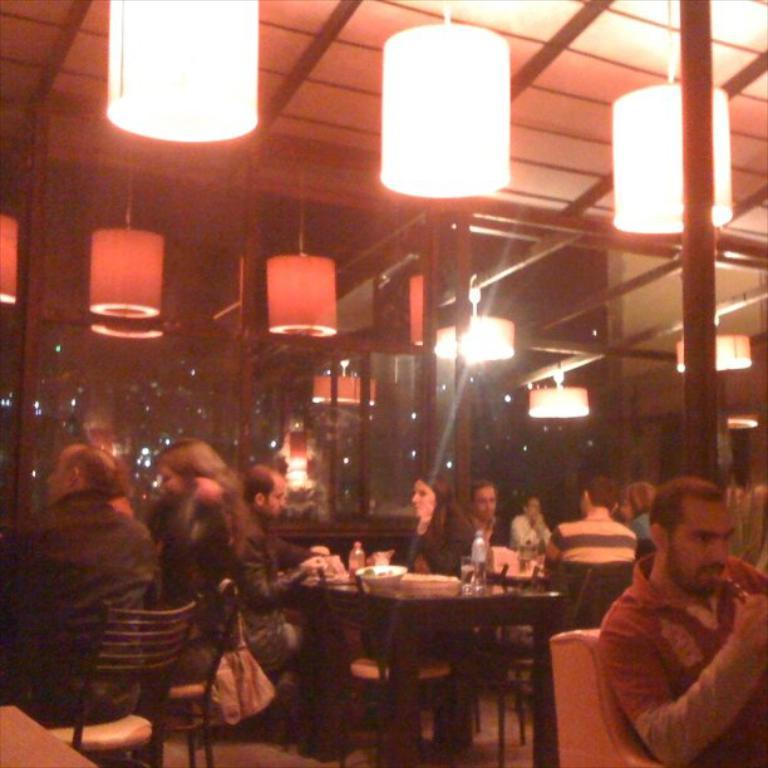How many people are in the image? There is a group of people in the image. What are the people in the image doing? The people are sitting and having a meal. What is in front of the group of people? There is a table in front of the group. What items can be seen on the table? There are water bottles, glasses, and plates on the table. What type of lighting is present in the image? There are ceiling lights attached. What thoughts are the geese having while observing the people in the image? There are no geese present in the image, so it is not possible to determine their thoughts. 